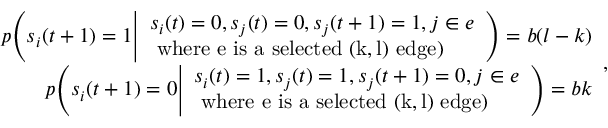<formula> <loc_0><loc_0><loc_500><loc_500>\begin{array} { r } { p \left ( s _ { i } ( t + 1 ) = 1 \left | \begin{array} { l } { s _ { i } ( t ) = 0 , s _ { j } ( t ) = 0 , s _ { j } ( t + 1 ) = 1 , j \in e } \\ { w h e r e e i s a s e l e c t e d ( k , l ) e d g e ) } \end{array} \right ) = b ( l - k ) } \\ { p \left ( s _ { i } ( t + 1 ) = 0 \right | \begin{array} { l } { s _ { i } ( t ) = 1 , s _ { j } ( t ) = 1 , s _ { j } ( t + 1 ) = 0 , j \in e } \\ { w h e r e e i s a s e l e c t e d ( k , l ) e d g e ) } \end{array} \right ) = b k } \end{array} ,</formula> 